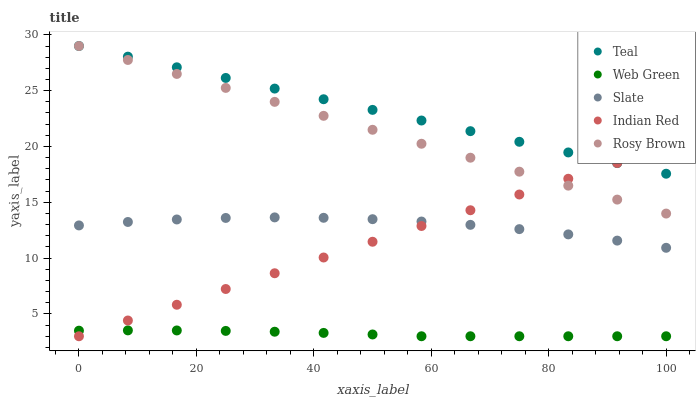Does Web Green have the minimum area under the curve?
Answer yes or no. Yes. Does Teal have the maximum area under the curve?
Answer yes or no. Yes. Does Slate have the minimum area under the curve?
Answer yes or no. No. Does Slate have the maximum area under the curve?
Answer yes or no. No. Is Indian Red the smoothest?
Answer yes or no. Yes. Is Slate the roughest?
Answer yes or no. Yes. Is Rosy Brown the smoothest?
Answer yes or no. No. Is Rosy Brown the roughest?
Answer yes or no. No. Does Indian Red have the lowest value?
Answer yes or no. Yes. Does Slate have the lowest value?
Answer yes or no. No. Does Teal have the highest value?
Answer yes or no. Yes. Does Slate have the highest value?
Answer yes or no. No. Is Slate less than Rosy Brown?
Answer yes or no. Yes. Is Rosy Brown greater than Web Green?
Answer yes or no. Yes. Does Teal intersect Rosy Brown?
Answer yes or no. Yes. Is Teal less than Rosy Brown?
Answer yes or no. No. Is Teal greater than Rosy Brown?
Answer yes or no. No. Does Slate intersect Rosy Brown?
Answer yes or no. No. 